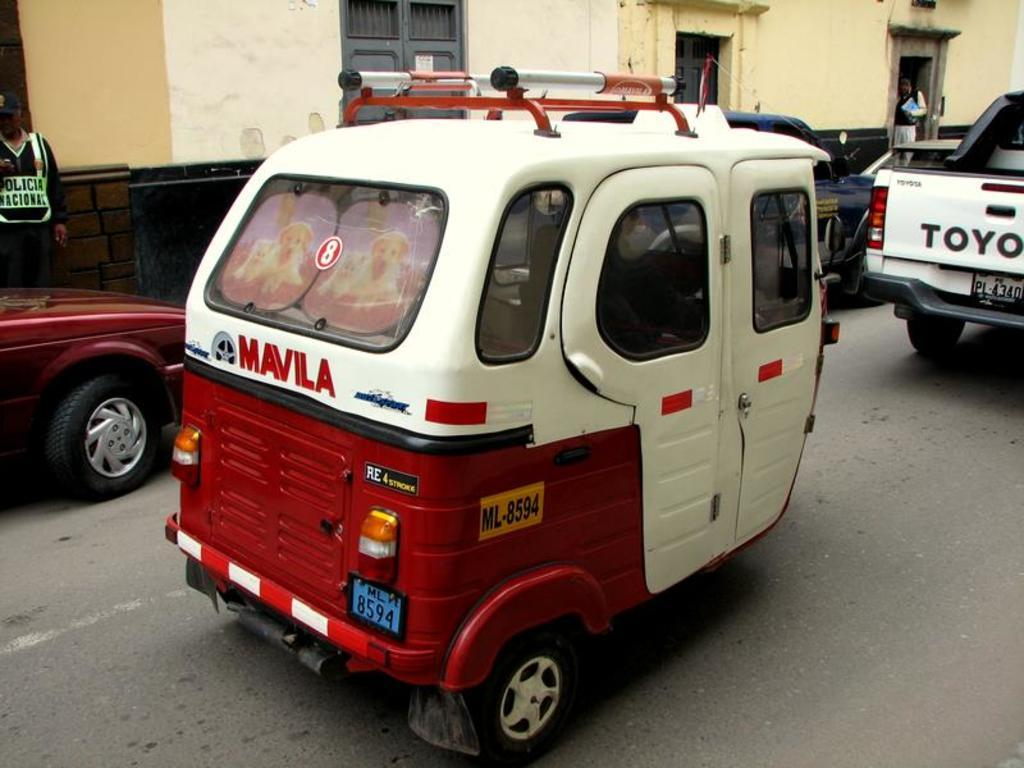What type of vehicle is in the image? There is a white and red auto in the image. What is the auto doing in the image? The auto is riding on the road. What other vehicle is present in the image? There is a white van in front of the auto. What can be seen behind the auto in the image? There is a yellow house with grey doors behind the auto. What type of cast can be seen on the driver's arm in the image? There is no cast visible on anyone's arm in the image, as the driver's arm is not shown. --- Facts: 1. There is a person holding a book in the image. 2. The person is sitting on a chair. 3. There is a table next to the chair. 4. The book has a blue cover. 5. The chair has a red cushion. Absurd Topics: parrot, ocean, bicycle Conversation: What is the person in the image holding? The person is holding a book in the image. What is the person's position in the image? The person is sitting on a chair. What is located next to the chair? There is a table next to the chair. What color is the book's cover? The book has a blue cover. What color is the chair's cushion? The chair has a red cushion. Reasoning: Let's think step by step in order to produce the conversation. We start by identifying the main subject in the image, which is the person holding a book. Then, we describe the person's position, which is sitting on a chair. Next, we mention the presence of a table next to the chair. Finally, we describe the colors of the book's cover and the chair's cushion. Absurd Question/Answer: Can you see a parrot sitting on the person's shoulder in the image? No, there is no parrot present in the image. 